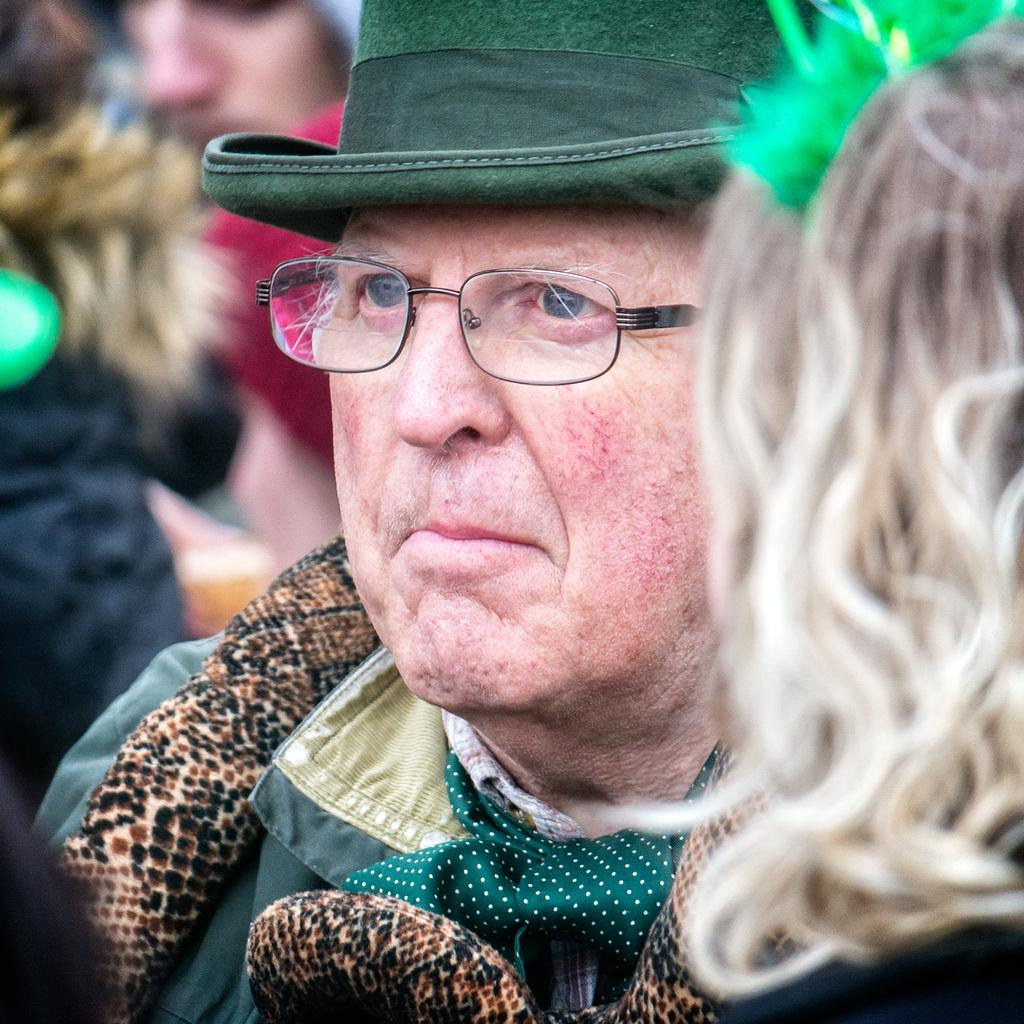How many people are in the image? There are people in the image, but the exact number is not specified. Can you describe the man in the center of the image? Yes, there is a man wearing a hat in the center of the image. Where is the kitten playing with the calculator near the drain in the image? There is no kitten, calculator, or drain present in the image. 